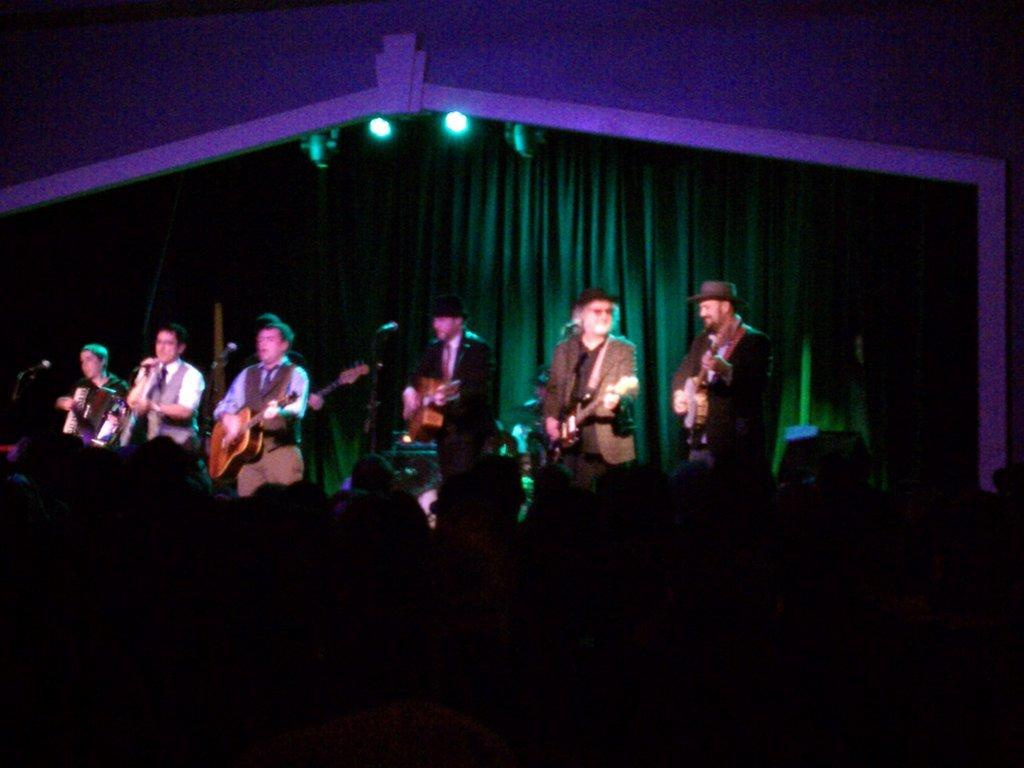What are the people on stage doing? The people on stage are playing musical instruments. What can be seen behind the stage? There is a curtain hanging behind the stage. What is present on the roof in the image? There are lights on the roof. What type of bead is being used as a decoration on the stage? There is no mention of a bead being used as a decoration on the stage in the image. Can you tell me how many people are attending the event in the image? The provided facts do not mention the number of people attending the event or if it is an event at all. 